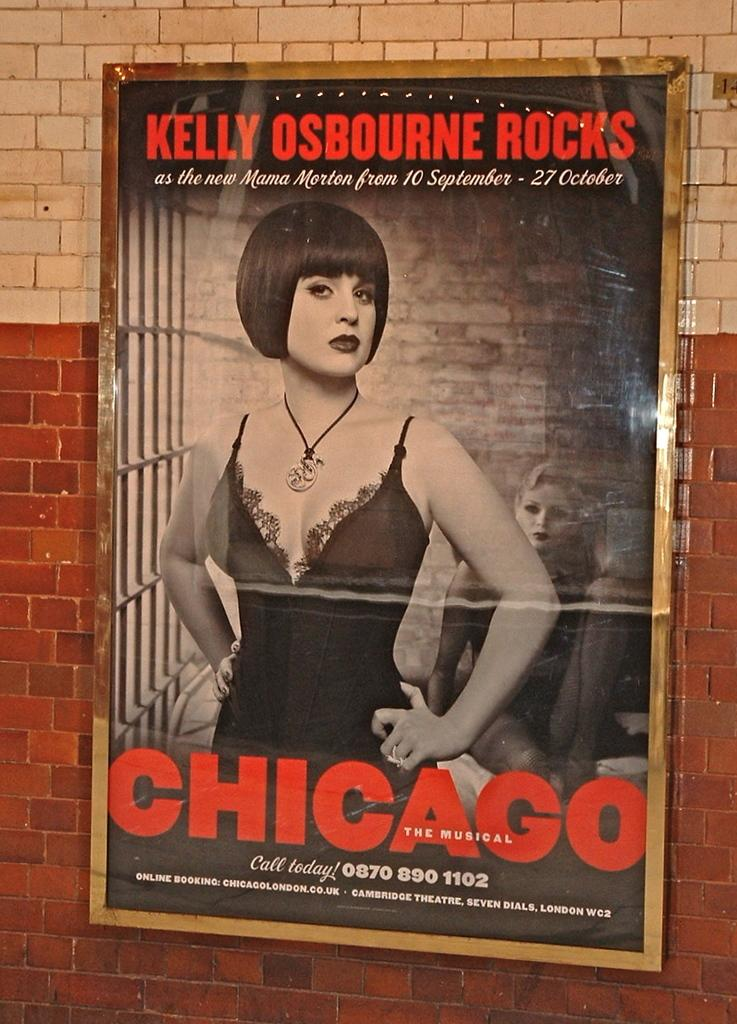<image>
Render a clear and concise summary of the photo. The movie poster says that Kelly Osbourne rocks in Chicago the musical. 